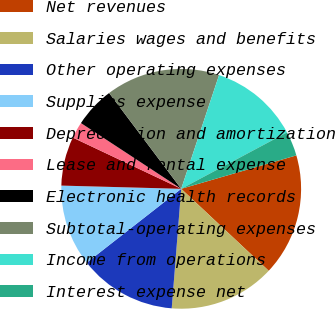Convert chart to OTSL. <chart><loc_0><loc_0><loc_500><loc_500><pie_chart><fcel>Net revenues<fcel>Salaries wages and benefits<fcel>Other operating expenses<fcel>Supplies expense<fcel>Depreciation and amortization<fcel>Lease and rental expense<fcel>Electronic health records<fcel>Subtotal-operating expenses<fcel>Income from operations<fcel>Interest expense net<nl><fcel>16.48%<fcel>14.28%<fcel>13.18%<fcel>10.99%<fcel>6.6%<fcel>2.21%<fcel>5.5%<fcel>15.38%<fcel>12.09%<fcel>3.3%<nl></chart> 